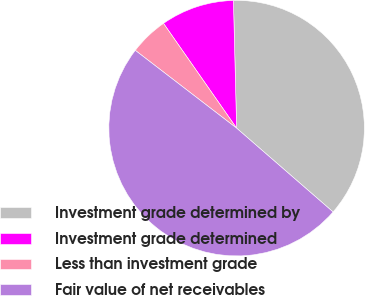Convert chart to OTSL. <chart><loc_0><loc_0><loc_500><loc_500><pie_chart><fcel>Investment grade determined by<fcel>Investment grade determined<fcel>Less than investment grade<fcel>Fair value of net receivables<nl><fcel>36.78%<fcel>9.3%<fcel>4.88%<fcel>49.04%<nl></chart> 